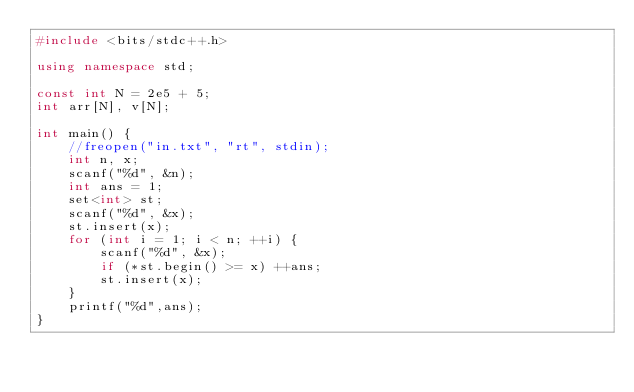<code> <loc_0><loc_0><loc_500><loc_500><_C++_>#include <bits/stdc++.h>

using namespace std;

const int N = 2e5 + 5;
int arr[N], v[N];

int main() {
    //freopen("in.txt", "rt", stdin);
    int n, x;
    scanf("%d", &n);
    int ans = 1;
    set<int> st;
    scanf("%d", &x);
    st.insert(x);
    for (int i = 1; i < n; ++i) {
        scanf("%d", &x);
        if (*st.begin() >= x) ++ans;
        st.insert(x);
    }
    printf("%d",ans);
}</code> 